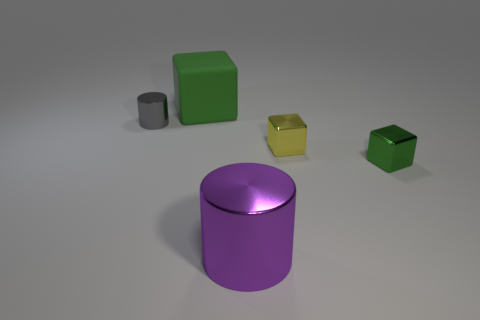Add 1 tiny blocks. How many objects exist? 6 Subtract all blocks. How many objects are left? 2 Subtract 0 cyan cylinders. How many objects are left? 5 Subtract all tiny red matte balls. Subtract all purple shiny objects. How many objects are left? 4 Add 2 small yellow objects. How many small yellow objects are left? 3 Add 1 small things. How many small things exist? 4 